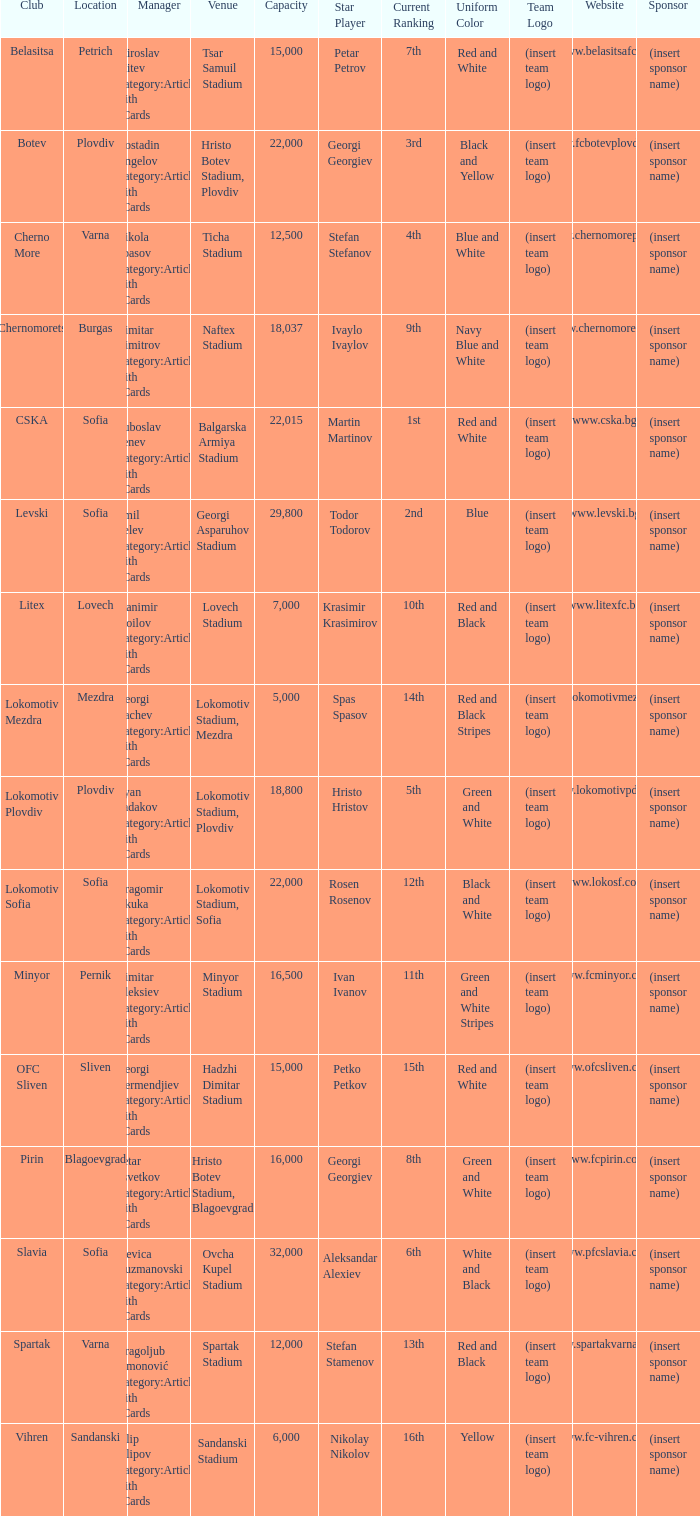What is the highest capacity for the venue of the club, vihren? 6000.0. 